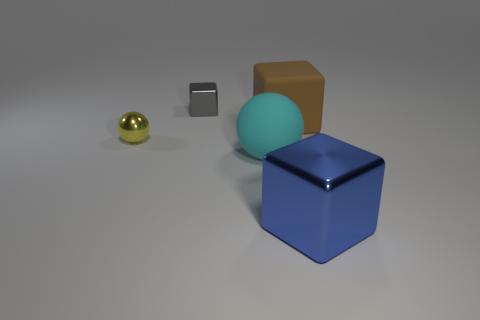Add 1 big red rubber things. How many objects exist? 6 Subtract all cubes. How many objects are left? 2 Add 3 tiny yellow shiny things. How many tiny yellow shiny things are left? 4 Add 3 large cyan matte objects. How many large cyan matte objects exist? 4 Subtract 0 yellow cubes. How many objects are left? 5 Subtract all small gray metallic cylinders. Subtract all tiny yellow metallic balls. How many objects are left? 4 